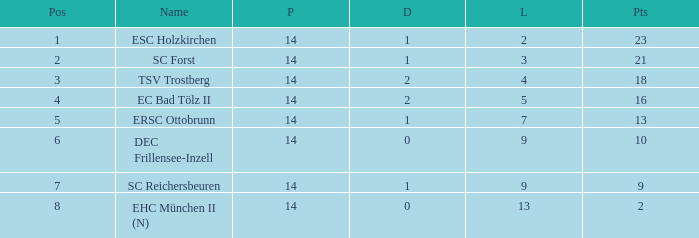Which Points is the highest one that has a Drawn smaller than 2, and a Name of esc holzkirchen, and Played smaller than 14? None. 